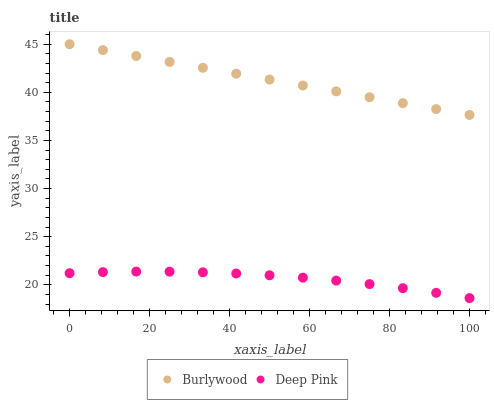Does Deep Pink have the minimum area under the curve?
Answer yes or no. Yes. Does Burlywood have the maximum area under the curve?
Answer yes or no. Yes. Does Deep Pink have the maximum area under the curve?
Answer yes or no. No. Is Burlywood the smoothest?
Answer yes or no. Yes. Is Deep Pink the roughest?
Answer yes or no. Yes. Is Deep Pink the smoothest?
Answer yes or no. No. Does Deep Pink have the lowest value?
Answer yes or no. Yes. Does Burlywood have the highest value?
Answer yes or no. Yes. Does Deep Pink have the highest value?
Answer yes or no. No. Is Deep Pink less than Burlywood?
Answer yes or no. Yes. Is Burlywood greater than Deep Pink?
Answer yes or no. Yes. Does Deep Pink intersect Burlywood?
Answer yes or no. No. 